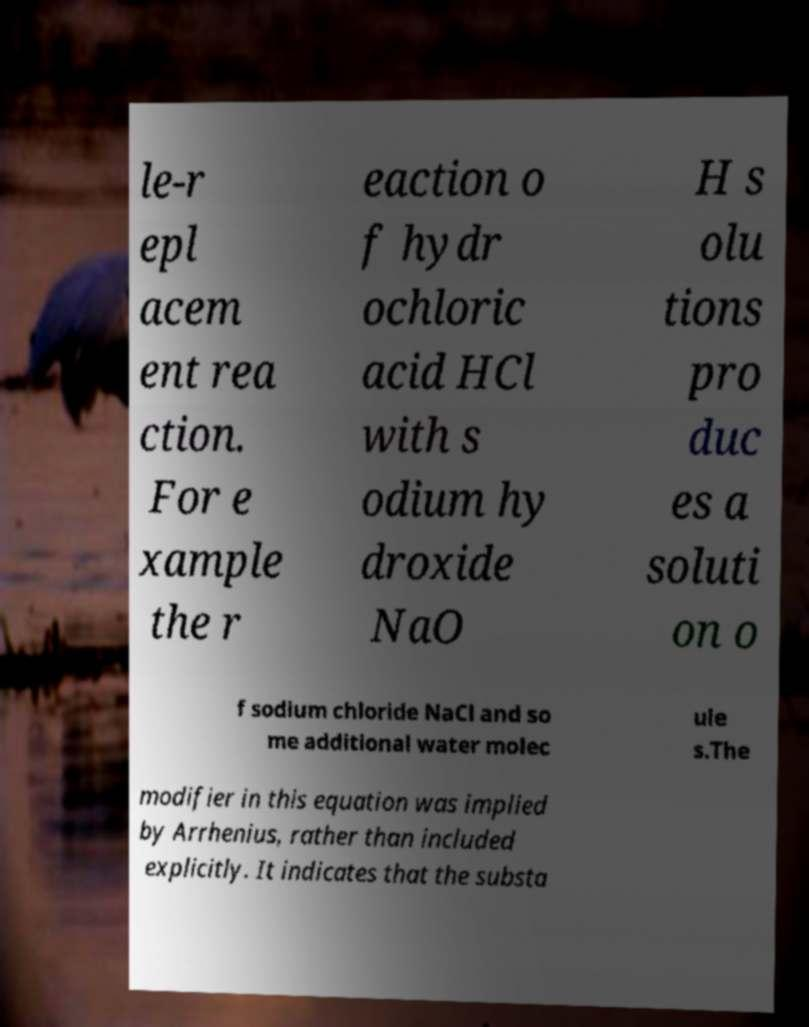What messages or text are displayed in this image? I need them in a readable, typed format. le-r epl acem ent rea ction. For e xample the r eaction o f hydr ochloric acid HCl with s odium hy droxide NaO H s olu tions pro duc es a soluti on o f sodium chloride NaCl and so me additional water molec ule s.The modifier in this equation was implied by Arrhenius, rather than included explicitly. It indicates that the substa 